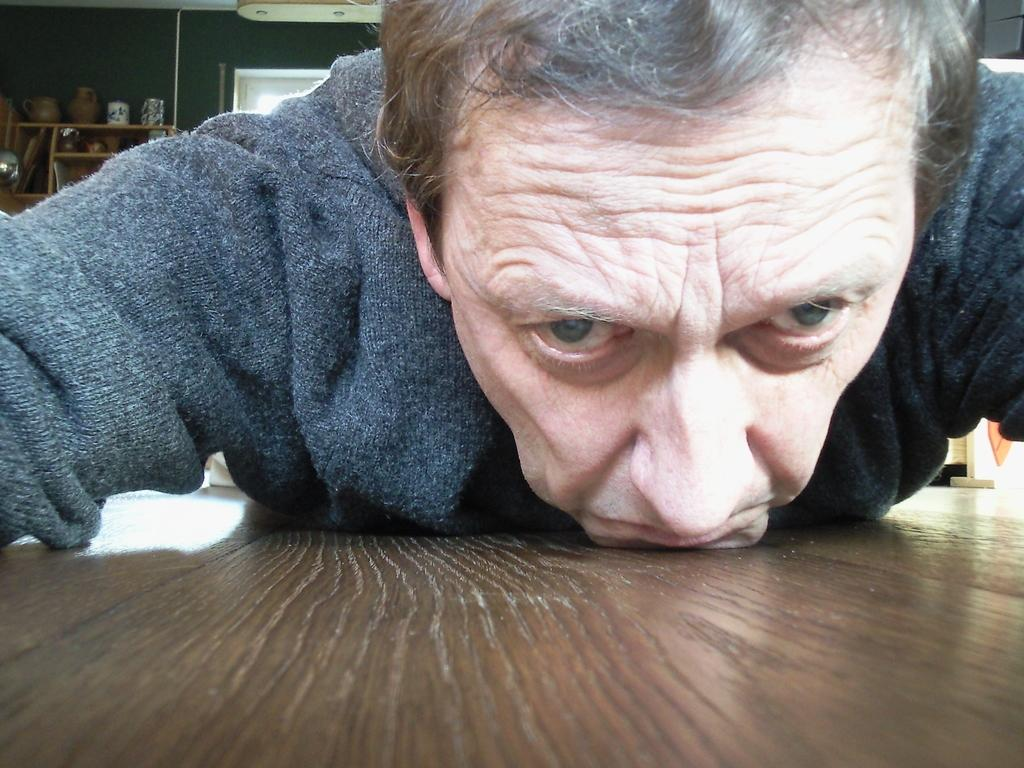What is the man doing in the image? The man is laying on a wooden object. What can be seen in the background of the image? There are objects in and on a rack in the background, and a wall is visible. What type of drink is the lawyer holding in the image? There is no lawyer or drink present in the image. 